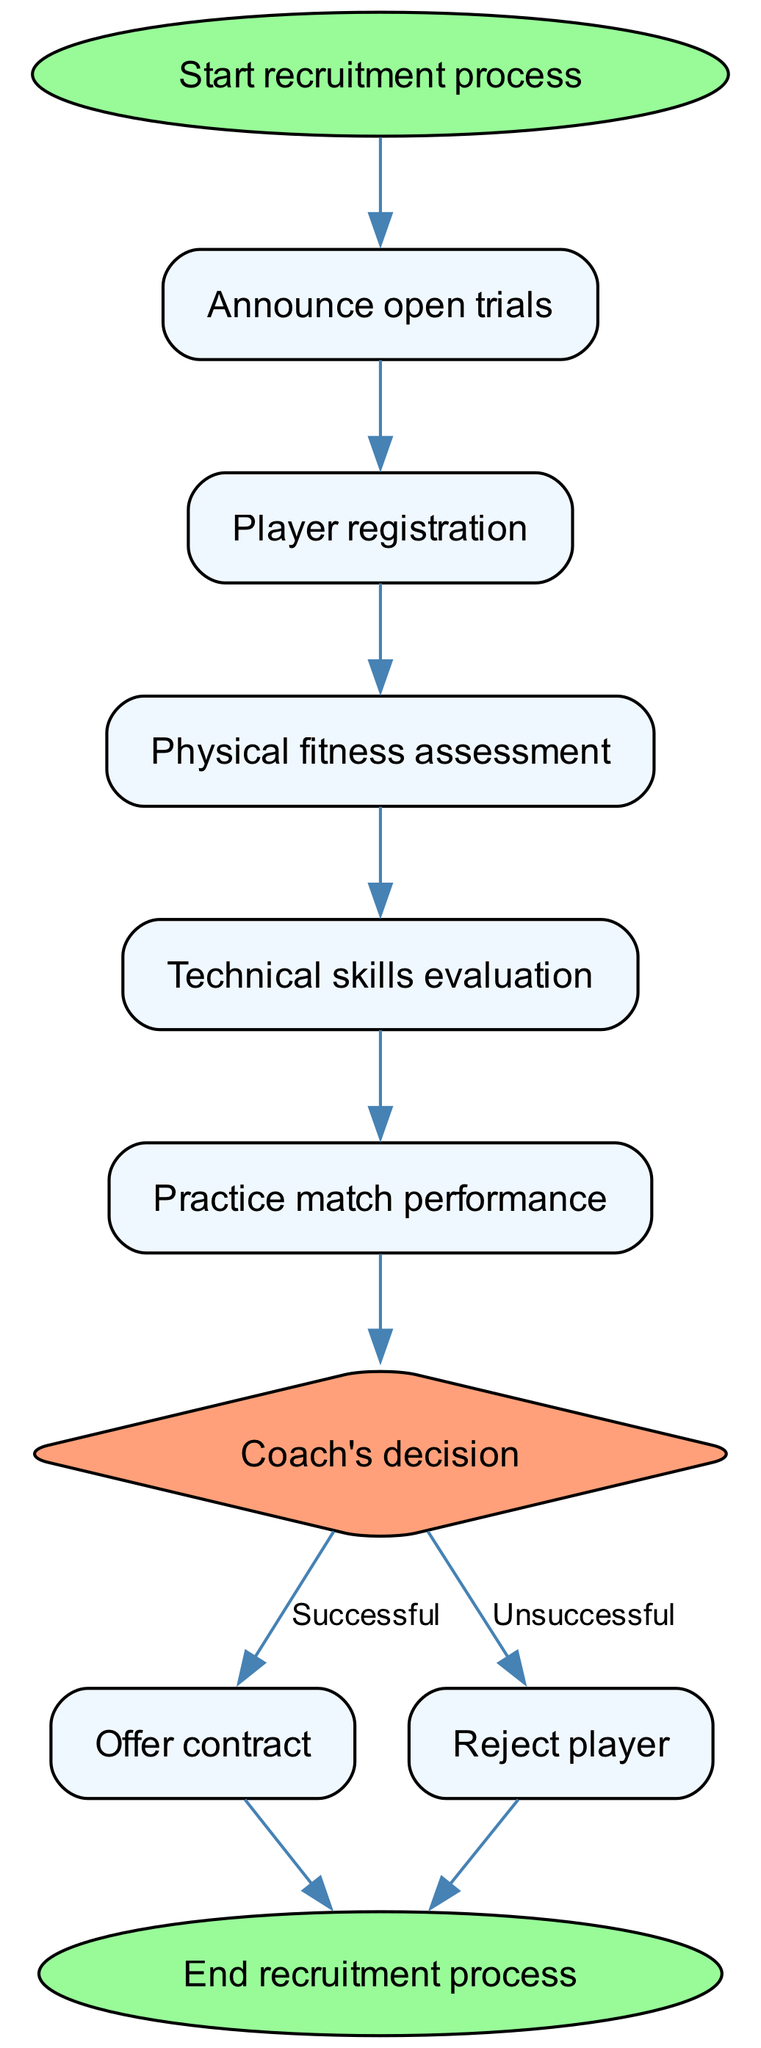What's the first step in the recruitment process? The diagram starts with the "Start recruitment process" node, which indicates that this is the initial stage of the flowchart.
Answer: Start recruitment process How many main evaluation stages are there in the player recruitment process? The main stages, excluding the start and end nodes, are Physical fitness assessment, Technical skills evaluation, and Practice match performance. This totals to three evaluation stages.
Answer: Three What decision does the coach make after evaluating players? The "Coach's decision" node indicates that the coach must make a decision regarding the players based on the evaluations performed in prior stages.
Answer: Coach's decision If the practice match performance is successful, what is the next step? According to the flowchart, if the match performance is deemed successful (as indicated in the decision node), the next step is to "Offer contract".
Answer: Offer contract What happens to the players who are rejected? From the "Reject player" node, it shows that players who are not successful in the evaluations simply go to the end of the recruitment process, meaning they do not receive a contract.
Answer: End recruitment process How many nodes are there in total in the diagram? By counting all nodes, including the start, evaluation stages, decisions, and end, there are ten nodes in total within this flowchart.
Answer: Ten Is the "Offer contract" action final or does it lead somewhere? After the "Offer contract" step, the flowchart leads directly to the end node, indicating that this action is the final step in the recruitment process.
Answer: Yes, it leads to the end What type of node is used to represent decisions in the flowchart? The "decision" node, as represented in the diagram, is depicted using a diamond shape, indicating its role in making choices within the process.
Answer: Diamond What does the second step in the recruitment process entail? The second step, indicated by the connection from "Announce open trials" to "Player registration," involves players signing up for the recruitment process.
Answer: Player registration 